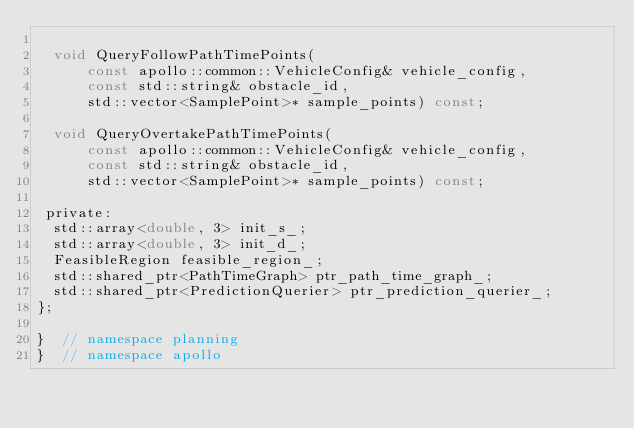<code> <loc_0><loc_0><loc_500><loc_500><_C_>
  void QueryFollowPathTimePoints(
      const apollo::common::VehicleConfig& vehicle_config,
      const std::string& obstacle_id,
      std::vector<SamplePoint>* sample_points) const;

  void QueryOvertakePathTimePoints(
      const apollo::common::VehicleConfig& vehicle_config,
      const std::string& obstacle_id,
      std::vector<SamplePoint>* sample_points) const;

 private:
  std::array<double, 3> init_s_;
  std::array<double, 3> init_d_;
  FeasibleRegion feasible_region_;
  std::shared_ptr<PathTimeGraph> ptr_path_time_graph_;
  std::shared_ptr<PredictionQuerier> ptr_prediction_querier_;
};

}  // namespace planning
}  // namespace apollo
</code> 